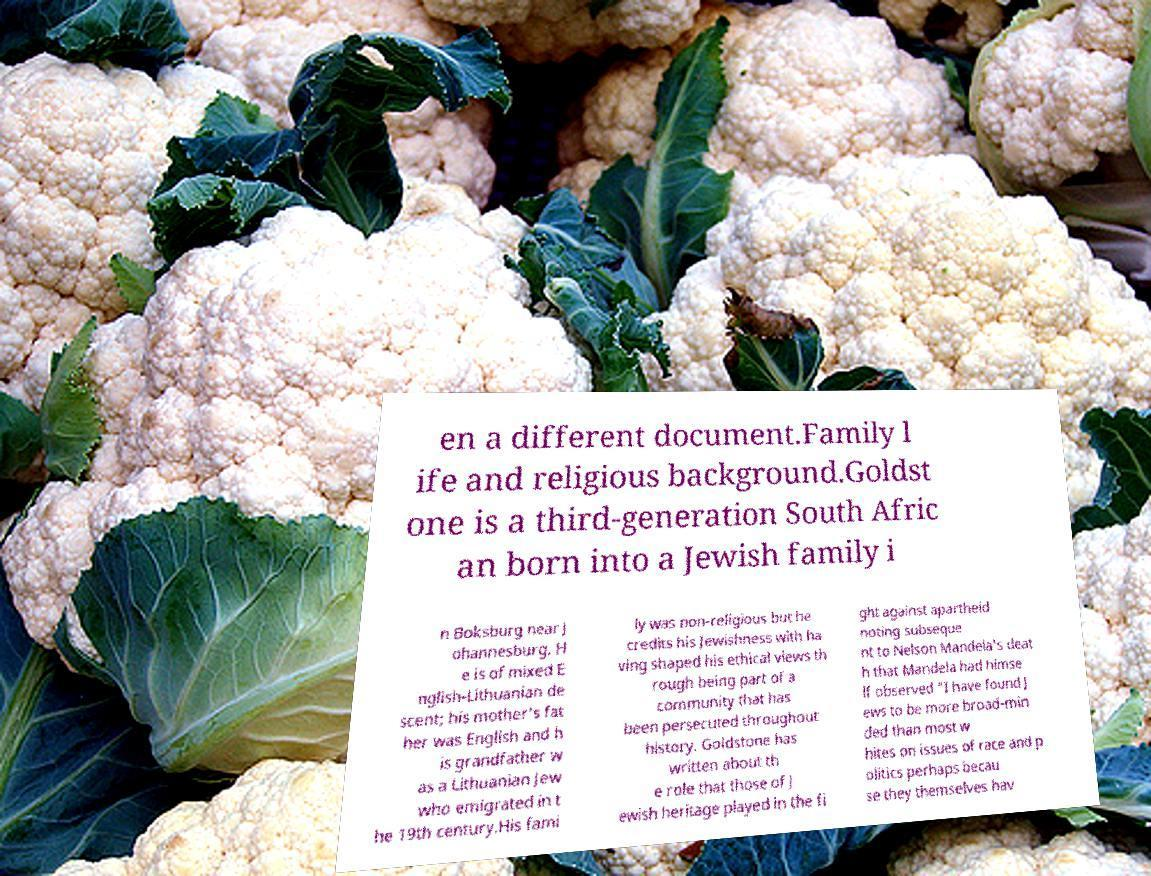For documentation purposes, I need the text within this image transcribed. Could you provide that? en a different document.Family l ife and religious background.Goldst one is a third-generation South Afric an born into a Jewish family i n Boksburg near J ohannesburg. H e is of mixed E nglish-Lithuanian de scent; his mother's fat her was English and h is grandfather w as a Lithuanian Jew who emigrated in t he 19th century.His fami ly was non-religious but he credits his Jewishness with ha ving shaped his ethical views th rough being part of a community that has been persecuted throughout history. Goldstone has written about th e role that those of J ewish heritage played in the fi ght against apartheid noting subseque nt to Nelson Mandela's deat h that Mandela had himse lf observed "I have found J ews to be more broad-min ded than most w hites on issues of race and p olitics perhaps becau se they themselves hav 